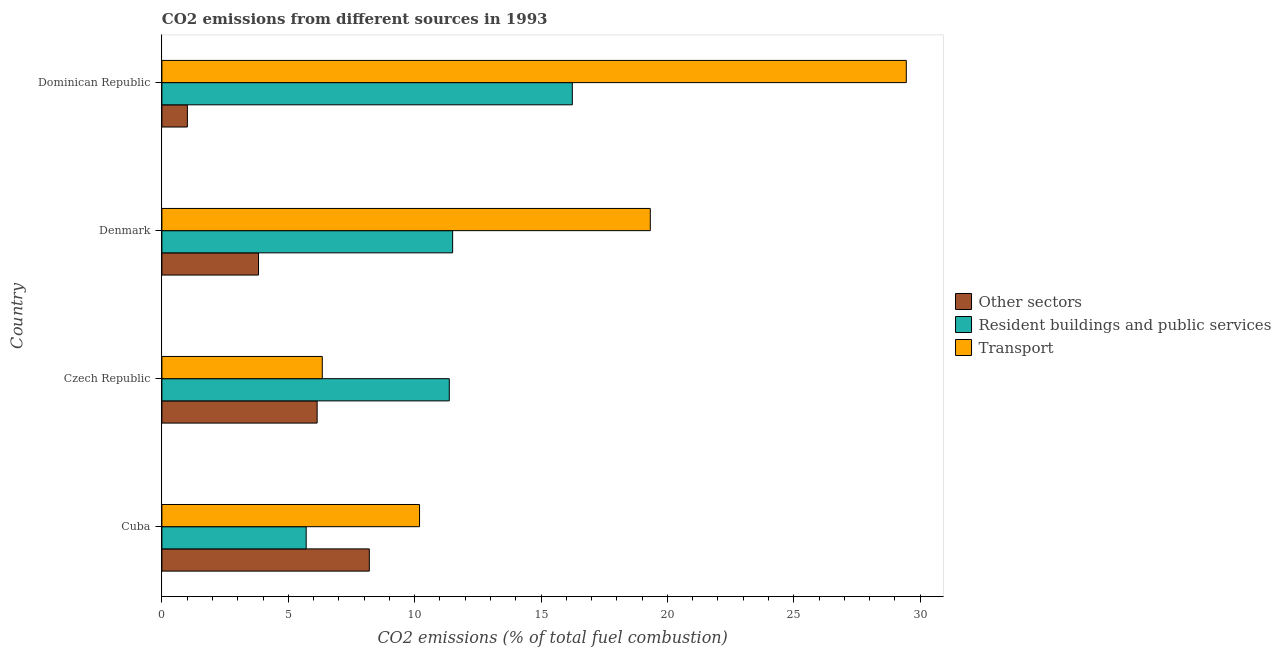Are the number of bars per tick equal to the number of legend labels?
Make the answer very short. Yes. Are the number of bars on each tick of the Y-axis equal?
Offer a terse response. Yes. How many bars are there on the 4th tick from the top?
Your answer should be very brief. 3. What is the label of the 1st group of bars from the top?
Provide a short and direct response. Dominican Republic. What is the percentage of co2 emissions from resident buildings and public services in Denmark?
Your answer should be very brief. 11.5. Across all countries, what is the maximum percentage of co2 emissions from other sectors?
Your response must be concise. 8.21. Across all countries, what is the minimum percentage of co2 emissions from other sectors?
Provide a short and direct response. 1.01. In which country was the percentage of co2 emissions from transport maximum?
Keep it short and to the point. Dominican Republic. In which country was the percentage of co2 emissions from other sectors minimum?
Offer a terse response. Dominican Republic. What is the total percentage of co2 emissions from transport in the graph?
Offer a very short reply. 65.31. What is the difference between the percentage of co2 emissions from resident buildings and public services in Cuba and that in Czech Republic?
Ensure brevity in your answer.  -5.66. What is the difference between the percentage of co2 emissions from other sectors in Dominican Republic and the percentage of co2 emissions from transport in Denmark?
Provide a short and direct response. -18.31. What is the average percentage of co2 emissions from resident buildings and public services per country?
Keep it short and to the point. 11.21. In how many countries, is the percentage of co2 emissions from other sectors greater than 11 %?
Your response must be concise. 0. What is the ratio of the percentage of co2 emissions from resident buildings and public services in Cuba to that in Czech Republic?
Offer a very short reply. 0.5. Is the percentage of co2 emissions from resident buildings and public services in Czech Republic less than that in Denmark?
Provide a short and direct response. Yes. What is the difference between the highest and the second highest percentage of co2 emissions from transport?
Ensure brevity in your answer.  10.13. What is the difference between the highest and the lowest percentage of co2 emissions from transport?
Offer a very short reply. 23.11. What does the 2nd bar from the top in Czech Republic represents?
Offer a very short reply. Resident buildings and public services. What does the 3rd bar from the bottom in Cuba represents?
Provide a short and direct response. Transport. Does the graph contain any zero values?
Give a very brief answer. No. How many legend labels are there?
Your response must be concise. 3. What is the title of the graph?
Ensure brevity in your answer.  CO2 emissions from different sources in 1993. Does "Ages 50+" appear as one of the legend labels in the graph?
Your answer should be compact. No. What is the label or title of the X-axis?
Your response must be concise. CO2 emissions (% of total fuel combustion). What is the CO2 emissions (% of total fuel combustion) in Other sectors in Cuba?
Your answer should be very brief. 8.21. What is the CO2 emissions (% of total fuel combustion) of Resident buildings and public services in Cuba?
Make the answer very short. 5.71. What is the CO2 emissions (% of total fuel combustion) of Transport in Cuba?
Give a very brief answer. 10.19. What is the CO2 emissions (% of total fuel combustion) of Other sectors in Czech Republic?
Make the answer very short. 6.14. What is the CO2 emissions (% of total fuel combustion) of Resident buildings and public services in Czech Republic?
Make the answer very short. 11.37. What is the CO2 emissions (% of total fuel combustion) of Transport in Czech Republic?
Offer a terse response. 6.35. What is the CO2 emissions (% of total fuel combustion) in Other sectors in Denmark?
Ensure brevity in your answer.  3.82. What is the CO2 emissions (% of total fuel combustion) of Resident buildings and public services in Denmark?
Offer a terse response. 11.5. What is the CO2 emissions (% of total fuel combustion) in Transport in Denmark?
Keep it short and to the point. 19.32. What is the CO2 emissions (% of total fuel combustion) of Other sectors in Dominican Republic?
Your answer should be very brief. 1.01. What is the CO2 emissions (% of total fuel combustion) of Resident buildings and public services in Dominican Republic?
Provide a succinct answer. 16.24. What is the CO2 emissions (% of total fuel combustion) of Transport in Dominican Republic?
Your answer should be compact. 29.45. Across all countries, what is the maximum CO2 emissions (% of total fuel combustion) in Other sectors?
Your response must be concise. 8.21. Across all countries, what is the maximum CO2 emissions (% of total fuel combustion) of Resident buildings and public services?
Provide a succinct answer. 16.24. Across all countries, what is the maximum CO2 emissions (% of total fuel combustion) in Transport?
Provide a short and direct response. 29.45. Across all countries, what is the minimum CO2 emissions (% of total fuel combustion) of Other sectors?
Your answer should be compact. 1.01. Across all countries, what is the minimum CO2 emissions (% of total fuel combustion) of Resident buildings and public services?
Offer a very short reply. 5.71. Across all countries, what is the minimum CO2 emissions (% of total fuel combustion) of Transport?
Give a very brief answer. 6.35. What is the total CO2 emissions (% of total fuel combustion) in Other sectors in the graph?
Make the answer very short. 19.18. What is the total CO2 emissions (% of total fuel combustion) of Resident buildings and public services in the graph?
Provide a short and direct response. 44.82. What is the total CO2 emissions (% of total fuel combustion) in Transport in the graph?
Ensure brevity in your answer.  65.31. What is the difference between the CO2 emissions (% of total fuel combustion) of Other sectors in Cuba and that in Czech Republic?
Offer a terse response. 2.06. What is the difference between the CO2 emissions (% of total fuel combustion) in Resident buildings and public services in Cuba and that in Czech Republic?
Give a very brief answer. -5.66. What is the difference between the CO2 emissions (% of total fuel combustion) in Transport in Cuba and that in Czech Republic?
Provide a short and direct response. 3.85. What is the difference between the CO2 emissions (% of total fuel combustion) in Other sectors in Cuba and that in Denmark?
Keep it short and to the point. 4.38. What is the difference between the CO2 emissions (% of total fuel combustion) in Resident buildings and public services in Cuba and that in Denmark?
Offer a terse response. -5.79. What is the difference between the CO2 emissions (% of total fuel combustion) of Transport in Cuba and that in Denmark?
Provide a short and direct response. -9.13. What is the difference between the CO2 emissions (% of total fuel combustion) in Other sectors in Cuba and that in Dominican Republic?
Your response must be concise. 7.2. What is the difference between the CO2 emissions (% of total fuel combustion) of Resident buildings and public services in Cuba and that in Dominican Republic?
Offer a terse response. -10.53. What is the difference between the CO2 emissions (% of total fuel combustion) in Transport in Cuba and that in Dominican Republic?
Offer a terse response. -19.26. What is the difference between the CO2 emissions (% of total fuel combustion) of Other sectors in Czech Republic and that in Denmark?
Offer a very short reply. 2.32. What is the difference between the CO2 emissions (% of total fuel combustion) of Resident buildings and public services in Czech Republic and that in Denmark?
Make the answer very short. -0.13. What is the difference between the CO2 emissions (% of total fuel combustion) in Transport in Czech Republic and that in Denmark?
Provide a short and direct response. -12.98. What is the difference between the CO2 emissions (% of total fuel combustion) in Other sectors in Czech Republic and that in Dominican Republic?
Offer a very short reply. 5.13. What is the difference between the CO2 emissions (% of total fuel combustion) in Resident buildings and public services in Czech Republic and that in Dominican Republic?
Your answer should be very brief. -4.87. What is the difference between the CO2 emissions (% of total fuel combustion) in Transport in Czech Republic and that in Dominican Republic?
Provide a short and direct response. -23.11. What is the difference between the CO2 emissions (% of total fuel combustion) in Other sectors in Denmark and that in Dominican Republic?
Keep it short and to the point. 2.81. What is the difference between the CO2 emissions (% of total fuel combustion) of Resident buildings and public services in Denmark and that in Dominican Republic?
Provide a succinct answer. -4.73. What is the difference between the CO2 emissions (% of total fuel combustion) in Transport in Denmark and that in Dominican Republic?
Your answer should be very brief. -10.13. What is the difference between the CO2 emissions (% of total fuel combustion) in Other sectors in Cuba and the CO2 emissions (% of total fuel combustion) in Resident buildings and public services in Czech Republic?
Offer a terse response. -3.16. What is the difference between the CO2 emissions (% of total fuel combustion) in Other sectors in Cuba and the CO2 emissions (% of total fuel combustion) in Transport in Czech Republic?
Provide a short and direct response. 1.86. What is the difference between the CO2 emissions (% of total fuel combustion) of Resident buildings and public services in Cuba and the CO2 emissions (% of total fuel combustion) of Transport in Czech Republic?
Ensure brevity in your answer.  -0.64. What is the difference between the CO2 emissions (% of total fuel combustion) in Other sectors in Cuba and the CO2 emissions (% of total fuel combustion) in Resident buildings and public services in Denmark?
Your response must be concise. -3.3. What is the difference between the CO2 emissions (% of total fuel combustion) of Other sectors in Cuba and the CO2 emissions (% of total fuel combustion) of Transport in Denmark?
Make the answer very short. -11.12. What is the difference between the CO2 emissions (% of total fuel combustion) in Resident buildings and public services in Cuba and the CO2 emissions (% of total fuel combustion) in Transport in Denmark?
Your answer should be very brief. -13.61. What is the difference between the CO2 emissions (% of total fuel combustion) of Other sectors in Cuba and the CO2 emissions (% of total fuel combustion) of Resident buildings and public services in Dominican Republic?
Provide a succinct answer. -8.03. What is the difference between the CO2 emissions (% of total fuel combustion) in Other sectors in Cuba and the CO2 emissions (% of total fuel combustion) in Transport in Dominican Republic?
Your answer should be very brief. -21.25. What is the difference between the CO2 emissions (% of total fuel combustion) of Resident buildings and public services in Cuba and the CO2 emissions (% of total fuel combustion) of Transport in Dominican Republic?
Make the answer very short. -23.74. What is the difference between the CO2 emissions (% of total fuel combustion) in Other sectors in Czech Republic and the CO2 emissions (% of total fuel combustion) in Resident buildings and public services in Denmark?
Ensure brevity in your answer.  -5.36. What is the difference between the CO2 emissions (% of total fuel combustion) of Other sectors in Czech Republic and the CO2 emissions (% of total fuel combustion) of Transport in Denmark?
Your response must be concise. -13.18. What is the difference between the CO2 emissions (% of total fuel combustion) in Resident buildings and public services in Czech Republic and the CO2 emissions (% of total fuel combustion) in Transport in Denmark?
Your answer should be compact. -7.95. What is the difference between the CO2 emissions (% of total fuel combustion) in Other sectors in Czech Republic and the CO2 emissions (% of total fuel combustion) in Resident buildings and public services in Dominican Republic?
Your answer should be compact. -10.1. What is the difference between the CO2 emissions (% of total fuel combustion) in Other sectors in Czech Republic and the CO2 emissions (% of total fuel combustion) in Transport in Dominican Republic?
Keep it short and to the point. -23.31. What is the difference between the CO2 emissions (% of total fuel combustion) in Resident buildings and public services in Czech Republic and the CO2 emissions (% of total fuel combustion) in Transport in Dominican Republic?
Your response must be concise. -18.08. What is the difference between the CO2 emissions (% of total fuel combustion) of Other sectors in Denmark and the CO2 emissions (% of total fuel combustion) of Resident buildings and public services in Dominican Republic?
Offer a terse response. -12.41. What is the difference between the CO2 emissions (% of total fuel combustion) of Other sectors in Denmark and the CO2 emissions (% of total fuel combustion) of Transport in Dominican Republic?
Give a very brief answer. -25.63. What is the difference between the CO2 emissions (% of total fuel combustion) in Resident buildings and public services in Denmark and the CO2 emissions (% of total fuel combustion) in Transport in Dominican Republic?
Offer a very short reply. -17.95. What is the average CO2 emissions (% of total fuel combustion) in Other sectors per country?
Offer a terse response. 4.79. What is the average CO2 emissions (% of total fuel combustion) of Resident buildings and public services per country?
Provide a succinct answer. 11.2. What is the average CO2 emissions (% of total fuel combustion) in Transport per country?
Provide a succinct answer. 16.33. What is the difference between the CO2 emissions (% of total fuel combustion) in Other sectors and CO2 emissions (% of total fuel combustion) in Resident buildings and public services in Cuba?
Your answer should be very brief. 2.5. What is the difference between the CO2 emissions (% of total fuel combustion) in Other sectors and CO2 emissions (% of total fuel combustion) in Transport in Cuba?
Offer a very short reply. -1.99. What is the difference between the CO2 emissions (% of total fuel combustion) in Resident buildings and public services and CO2 emissions (% of total fuel combustion) in Transport in Cuba?
Offer a terse response. -4.49. What is the difference between the CO2 emissions (% of total fuel combustion) of Other sectors and CO2 emissions (% of total fuel combustion) of Resident buildings and public services in Czech Republic?
Give a very brief answer. -5.23. What is the difference between the CO2 emissions (% of total fuel combustion) of Other sectors and CO2 emissions (% of total fuel combustion) of Transport in Czech Republic?
Keep it short and to the point. -0.2. What is the difference between the CO2 emissions (% of total fuel combustion) in Resident buildings and public services and CO2 emissions (% of total fuel combustion) in Transport in Czech Republic?
Offer a very short reply. 5.02. What is the difference between the CO2 emissions (% of total fuel combustion) of Other sectors and CO2 emissions (% of total fuel combustion) of Resident buildings and public services in Denmark?
Make the answer very short. -7.68. What is the difference between the CO2 emissions (% of total fuel combustion) of Other sectors and CO2 emissions (% of total fuel combustion) of Transport in Denmark?
Ensure brevity in your answer.  -15.5. What is the difference between the CO2 emissions (% of total fuel combustion) in Resident buildings and public services and CO2 emissions (% of total fuel combustion) in Transport in Denmark?
Ensure brevity in your answer.  -7.82. What is the difference between the CO2 emissions (% of total fuel combustion) of Other sectors and CO2 emissions (% of total fuel combustion) of Resident buildings and public services in Dominican Republic?
Provide a short and direct response. -15.23. What is the difference between the CO2 emissions (% of total fuel combustion) in Other sectors and CO2 emissions (% of total fuel combustion) in Transport in Dominican Republic?
Your response must be concise. -28.44. What is the difference between the CO2 emissions (% of total fuel combustion) of Resident buildings and public services and CO2 emissions (% of total fuel combustion) of Transport in Dominican Republic?
Make the answer very short. -13.21. What is the ratio of the CO2 emissions (% of total fuel combustion) in Other sectors in Cuba to that in Czech Republic?
Offer a terse response. 1.34. What is the ratio of the CO2 emissions (% of total fuel combustion) of Resident buildings and public services in Cuba to that in Czech Republic?
Your answer should be very brief. 0.5. What is the ratio of the CO2 emissions (% of total fuel combustion) of Transport in Cuba to that in Czech Republic?
Your answer should be compact. 1.61. What is the ratio of the CO2 emissions (% of total fuel combustion) of Other sectors in Cuba to that in Denmark?
Provide a short and direct response. 2.15. What is the ratio of the CO2 emissions (% of total fuel combustion) of Resident buildings and public services in Cuba to that in Denmark?
Provide a short and direct response. 0.5. What is the ratio of the CO2 emissions (% of total fuel combustion) in Transport in Cuba to that in Denmark?
Your response must be concise. 0.53. What is the ratio of the CO2 emissions (% of total fuel combustion) in Other sectors in Cuba to that in Dominican Republic?
Your answer should be very brief. 8.14. What is the ratio of the CO2 emissions (% of total fuel combustion) of Resident buildings and public services in Cuba to that in Dominican Republic?
Keep it short and to the point. 0.35. What is the ratio of the CO2 emissions (% of total fuel combustion) in Transport in Cuba to that in Dominican Republic?
Provide a short and direct response. 0.35. What is the ratio of the CO2 emissions (% of total fuel combustion) in Other sectors in Czech Republic to that in Denmark?
Give a very brief answer. 1.61. What is the ratio of the CO2 emissions (% of total fuel combustion) in Resident buildings and public services in Czech Republic to that in Denmark?
Your answer should be compact. 0.99. What is the ratio of the CO2 emissions (% of total fuel combustion) in Transport in Czech Republic to that in Denmark?
Provide a succinct answer. 0.33. What is the ratio of the CO2 emissions (% of total fuel combustion) of Other sectors in Czech Republic to that in Dominican Republic?
Provide a succinct answer. 6.09. What is the ratio of the CO2 emissions (% of total fuel combustion) of Resident buildings and public services in Czech Republic to that in Dominican Republic?
Your response must be concise. 0.7. What is the ratio of the CO2 emissions (% of total fuel combustion) in Transport in Czech Republic to that in Dominican Republic?
Offer a terse response. 0.22. What is the ratio of the CO2 emissions (% of total fuel combustion) of Other sectors in Denmark to that in Dominican Republic?
Your response must be concise. 3.79. What is the ratio of the CO2 emissions (% of total fuel combustion) in Resident buildings and public services in Denmark to that in Dominican Republic?
Ensure brevity in your answer.  0.71. What is the ratio of the CO2 emissions (% of total fuel combustion) of Transport in Denmark to that in Dominican Republic?
Provide a succinct answer. 0.66. What is the difference between the highest and the second highest CO2 emissions (% of total fuel combustion) in Other sectors?
Your answer should be very brief. 2.06. What is the difference between the highest and the second highest CO2 emissions (% of total fuel combustion) of Resident buildings and public services?
Make the answer very short. 4.73. What is the difference between the highest and the second highest CO2 emissions (% of total fuel combustion) of Transport?
Provide a short and direct response. 10.13. What is the difference between the highest and the lowest CO2 emissions (% of total fuel combustion) in Other sectors?
Your answer should be compact. 7.2. What is the difference between the highest and the lowest CO2 emissions (% of total fuel combustion) of Resident buildings and public services?
Offer a terse response. 10.53. What is the difference between the highest and the lowest CO2 emissions (% of total fuel combustion) in Transport?
Your response must be concise. 23.11. 